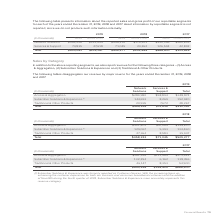According to Adtran's financial document, What was the total revenue from Access & Aggregation in 2019? According to the financial document, $348,874 (in thousands). The relevant text states: "Access & Aggregation $289,980 $58,894 $348,874..." Also, What was Subscriber Solutions & Experience formerly reported as? According to the financial document, Customer Devices.. The relevant text states: "er Solutions & Experience was formerly reported as Customer Devices. With the increasing focus on..." Also, What was the total revenue from Traditional & other Products? According to the financial document, 28,267 (in thousands). The relevant text states: "Traditional & Other Products 20,595 7,672 28,267..." Also, can you calculate: What is the difference in the total revenue from Access & Aggregation and Traditional & Other Products? Based on the calculation: 348,874-28,267, the result is 320607 (in thousands). This is based on the information: "Traditional & Other Products 20,595 7,672 28,267 Access & Aggregation $289,980 $58,894 $348,874..." The key data points involved are: 28,267, 348,874. Also, How many categories did total revenue exceed $100,000 thousand? Counting the relevant items in the document: Access & Aggregation, Subscriber Solutions & Experience, I find 2 instances. The key data points involved are: Access & Aggregation, Subscriber Solutions & Experience. Also, can you calculate: What is the total revenue from Network Solutions as a percentage of total revenue from all segments? Based on the calculation: 455,226/530,061, the result is 85.88 (percentage). This is based on the information: "Total $455,226 $74,835 $530,061 Total $455,226 $74,835 $530,061..." The key data points involved are: 455,226, 530,061. 